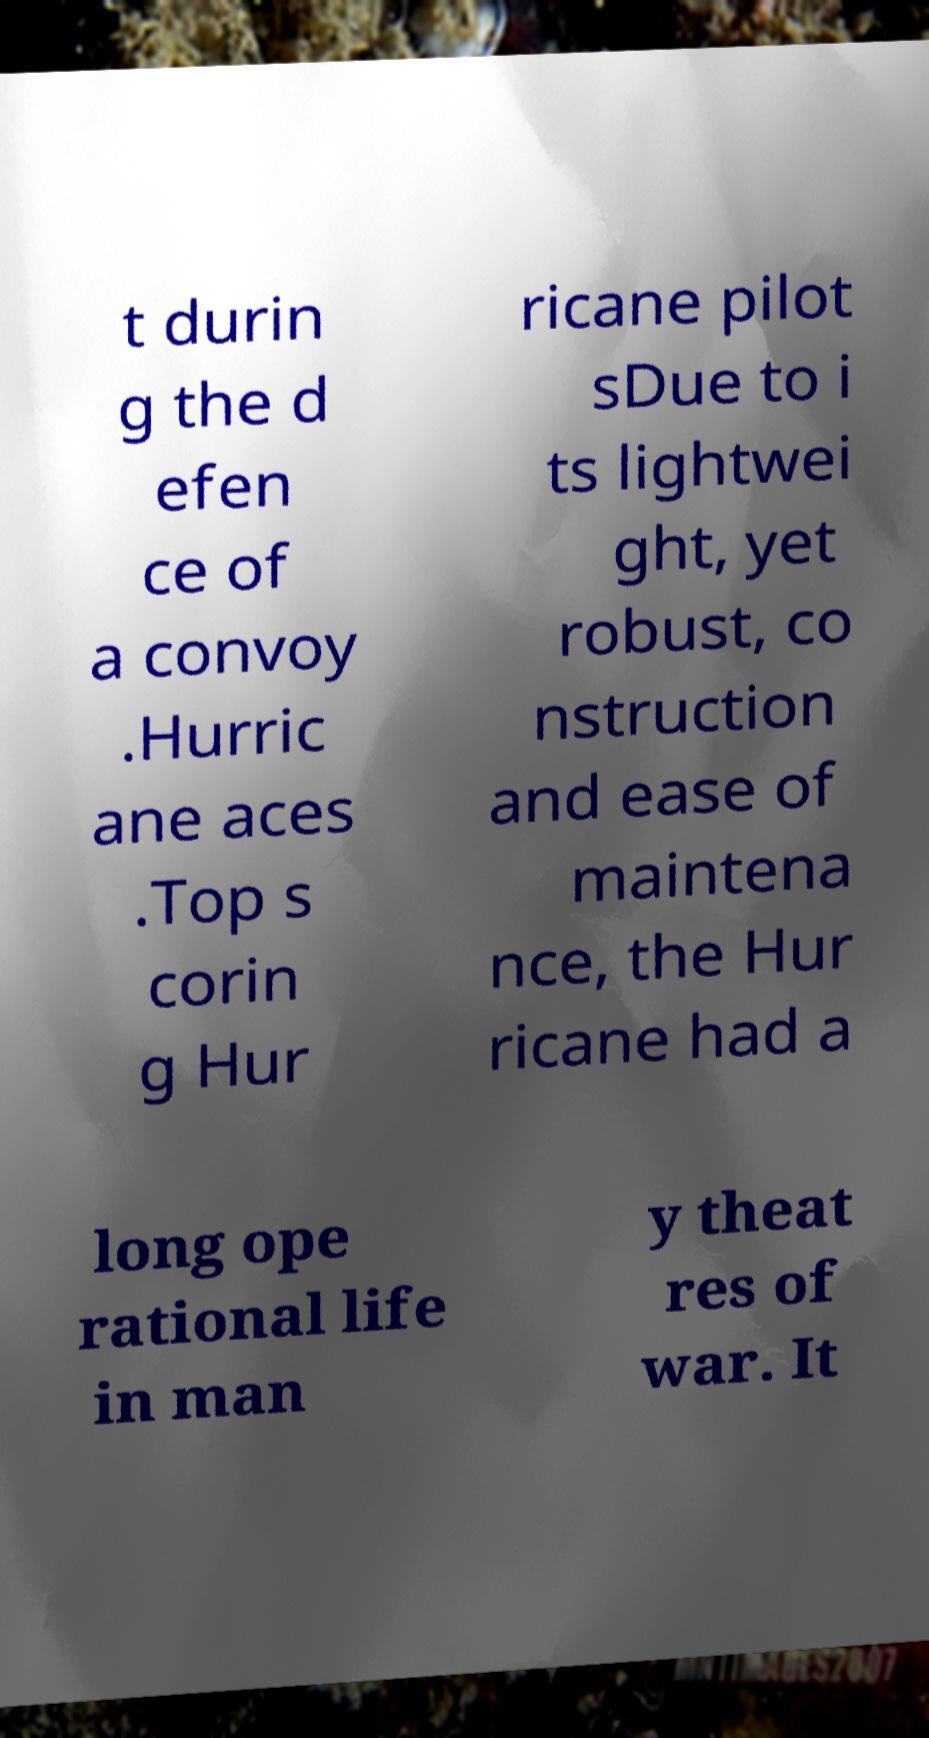Please read and relay the text visible in this image. What does it say? t durin g the d efen ce of a convoy .Hurric ane aces .Top s corin g Hur ricane pilot sDue to i ts lightwei ght, yet robust, co nstruction and ease of maintena nce, the Hur ricane had a long ope rational life in man y theat res of war. It 